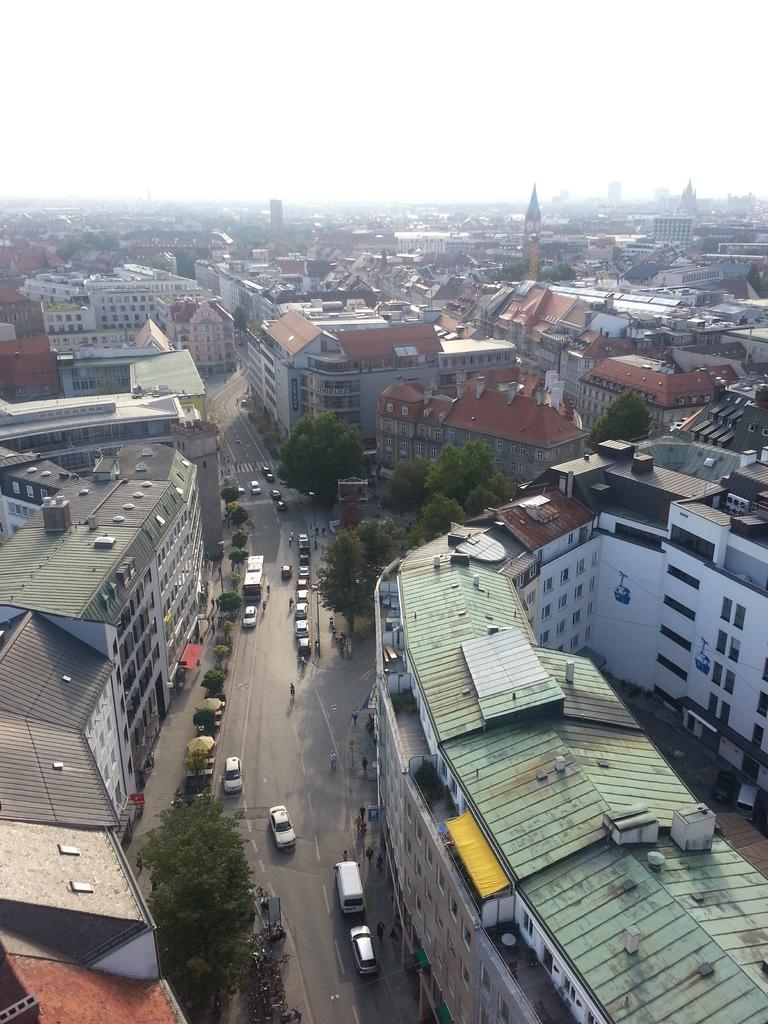What type of structures can be seen in the image? There are buildings in the image. What feature can be observed on the buildings? There are windows visible in the image. What type of natural elements are present in the image? There are trees in the image. What type of transportation can be seen on the road? There are vehicles on the road in the image. What activity are people engaged in on the road? People are walking on the road in the image. What is the color of the sky in the image? The sky appears to be white in color. Can you tell me how many goats are walking on the road in the image? There are no goats present in the image; people are walking on the road. What type of bike is being used to copy the buildings in the image? There is no bike or copying activity present in the image. 